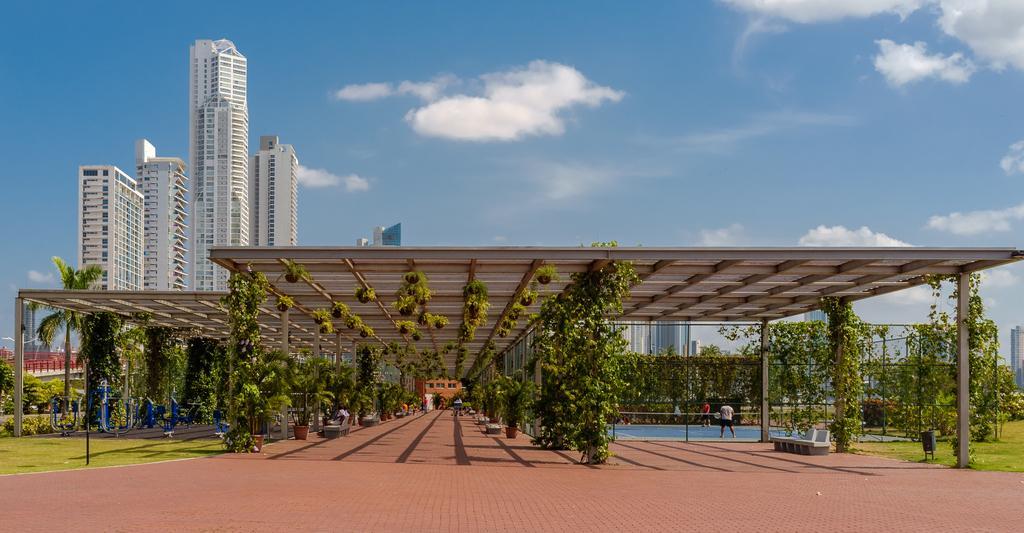How would you summarize this image in a sentence or two? In the picture there is a roof, there are many trees below the roof and on the right side there is a badminton court, there are few tall towers behind the roof. 